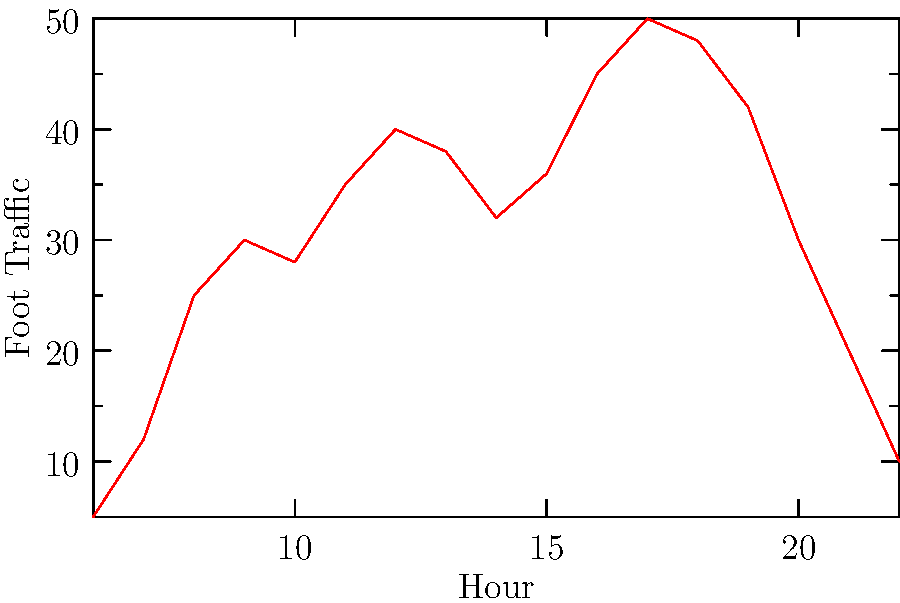Based on the line chart showing hourly foot traffic in your convenience store, what is the busiest hour of the day, and how might you adjust your staffing or inventory to accommodate this peak time? To answer this question, we need to analyze the line chart step-by-step:

1. Examine the x-axis (Hour) and y-axis (Foot Traffic) to understand the data representation.
2. Scan the line graph to identify the highest point, which represents the busiest hour.
3. The highest point on the graph corresponds to hour 17 (5 PM) with approximately 50 customers.
4. To accommodate this peak time:
   a) Increase staffing during the 4 PM to 6 PM window to handle the higher customer volume.
   b) Ensure inventory is well-stocked before this rush, particularly for popular items.
   c) Consider opening an additional checkout lane if possible during this time.
5. Also note the general trend:
   - Traffic increases steadily from opening until midday.
   - There's a slight dip in early afternoon before the evening peak.
   - Traffic decreases rapidly after 6 PM.

This analysis allows for optimized resource allocation throughout the day.
Answer: Busiest hour: 5 PM. Adjust by increasing staff and inventory for 4-6 PM rush. 